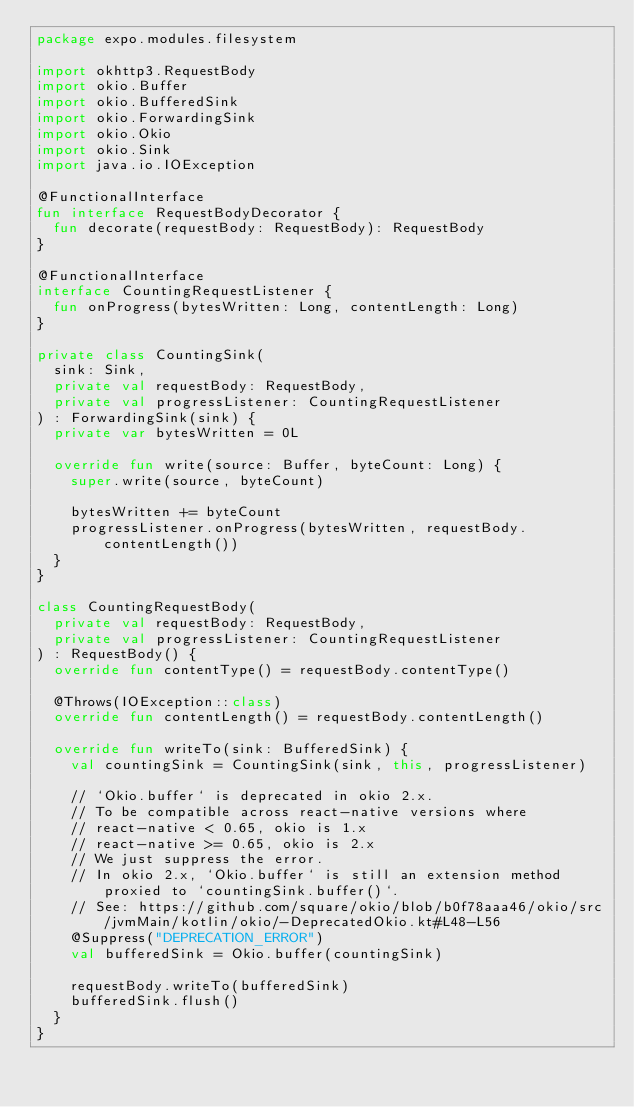<code> <loc_0><loc_0><loc_500><loc_500><_Kotlin_>package expo.modules.filesystem

import okhttp3.RequestBody
import okio.Buffer
import okio.BufferedSink
import okio.ForwardingSink
import okio.Okio
import okio.Sink
import java.io.IOException

@FunctionalInterface
fun interface RequestBodyDecorator {
  fun decorate(requestBody: RequestBody): RequestBody
}

@FunctionalInterface
interface CountingRequestListener {
  fun onProgress(bytesWritten: Long, contentLength: Long)
}

private class CountingSink(
  sink: Sink,
  private val requestBody: RequestBody,
  private val progressListener: CountingRequestListener
) : ForwardingSink(sink) {
  private var bytesWritten = 0L

  override fun write(source: Buffer, byteCount: Long) {
    super.write(source, byteCount)

    bytesWritten += byteCount
    progressListener.onProgress(bytesWritten, requestBody.contentLength())
  }
}

class CountingRequestBody(
  private val requestBody: RequestBody,
  private val progressListener: CountingRequestListener
) : RequestBody() {
  override fun contentType() = requestBody.contentType()

  @Throws(IOException::class)
  override fun contentLength() = requestBody.contentLength()

  override fun writeTo(sink: BufferedSink) {
    val countingSink = CountingSink(sink, this, progressListener)

    // `Okio.buffer` is deprecated in okio 2.x.
    // To be compatible across react-native versions where
    // react-native < 0.65, okio is 1.x
    // react-native >= 0.65, okio is 2.x
    // We just suppress the error.
    // In okio 2.x, `Okio.buffer` is still an extension method proxied to `countingSink.buffer()`.
    // See: https://github.com/square/okio/blob/b0f78aaa46/okio/src/jvmMain/kotlin/okio/-DeprecatedOkio.kt#L48-L56
    @Suppress("DEPRECATION_ERROR")
    val bufferedSink = Okio.buffer(countingSink)

    requestBody.writeTo(bufferedSink)
    bufferedSink.flush()
  }
}
</code> 